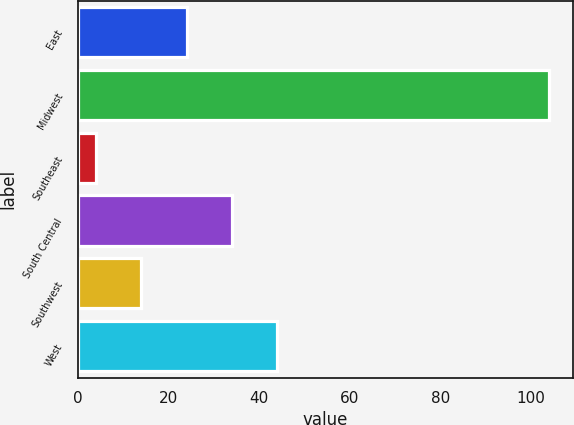<chart> <loc_0><loc_0><loc_500><loc_500><bar_chart><fcel>East<fcel>Midwest<fcel>Southeast<fcel>South Central<fcel>Southwest<fcel>West<nl><fcel>24<fcel>104<fcel>4<fcel>34<fcel>14<fcel>44<nl></chart> 